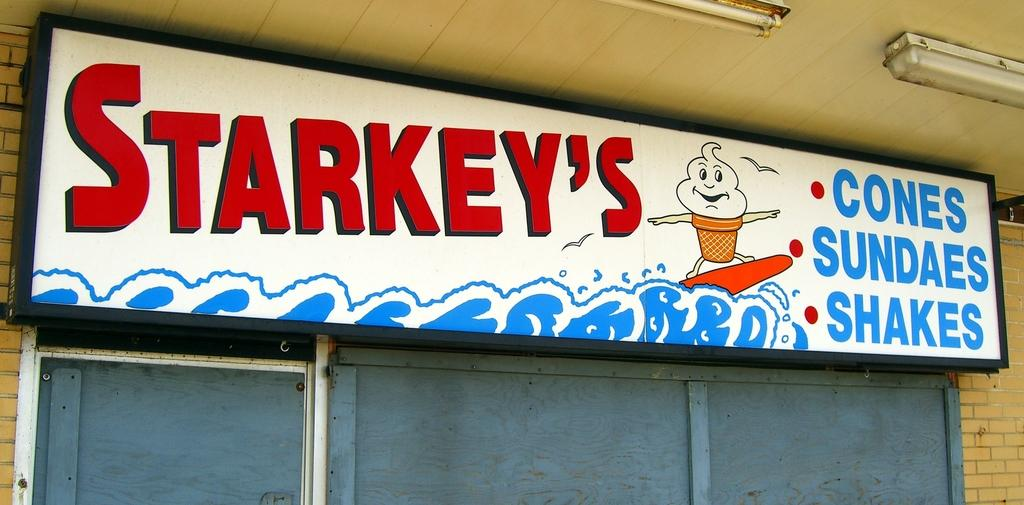<image>
Offer a succinct explanation of the picture presented. A sign hangs and advertises cones, sundaes, and shakes. 